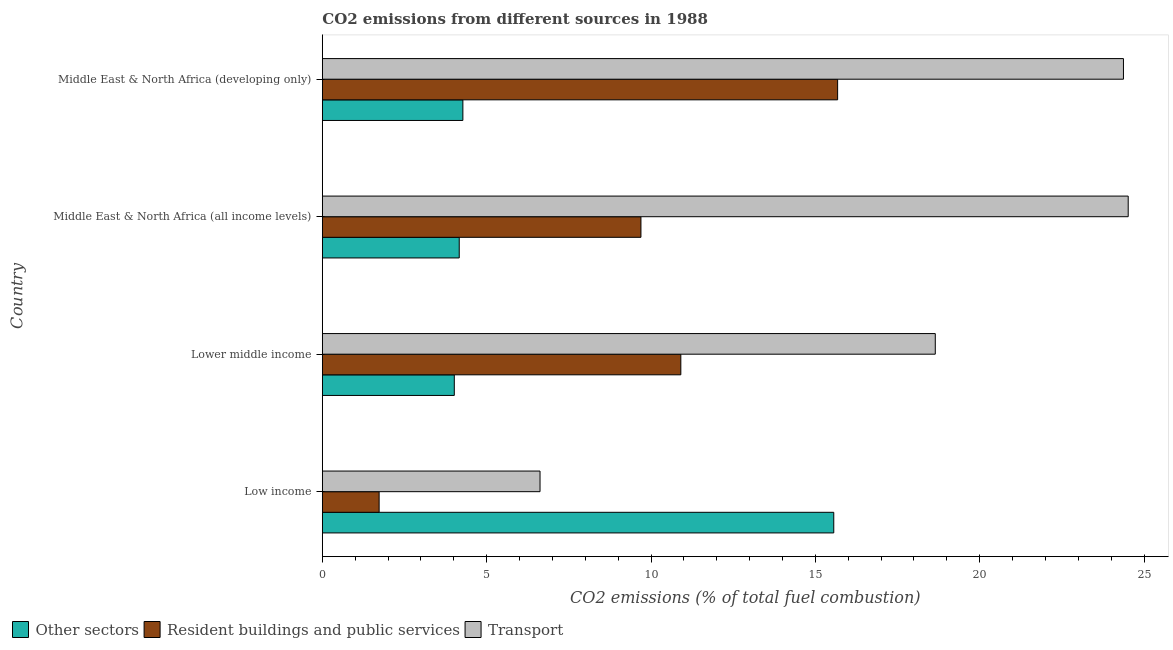How many different coloured bars are there?
Your answer should be very brief. 3. Are the number of bars per tick equal to the number of legend labels?
Your answer should be compact. Yes. Are the number of bars on each tick of the Y-axis equal?
Give a very brief answer. Yes. How many bars are there on the 3rd tick from the top?
Your answer should be compact. 3. What is the label of the 1st group of bars from the top?
Your response must be concise. Middle East & North Africa (developing only). What is the percentage of co2 emissions from other sectors in Lower middle income?
Offer a terse response. 4.02. Across all countries, what is the maximum percentage of co2 emissions from other sectors?
Offer a very short reply. 15.56. Across all countries, what is the minimum percentage of co2 emissions from resident buildings and public services?
Keep it short and to the point. 1.73. In which country was the percentage of co2 emissions from other sectors maximum?
Make the answer very short. Low income. What is the total percentage of co2 emissions from other sectors in the graph?
Provide a short and direct response. 28.02. What is the difference between the percentage of co2 emissions from transport in Lower middle income and that in Middle East & North Africa (developing only)?
Make the answer very short. -5.72. What is the difference between the percentage of co2 emissions from transport in Middle East & North Africa (all income levels) and the percentage of co2 emissions from resident buildings and public services in Middle East & North Africa (developing only)?
Your answer should be compact. 8.84. What is the average percentage of co2 emissions from other sectors per country?
Offer a terse response. 7. What is the difference between the percentage of co2 emissions from transport and percentage of co2 emissions from resident buildings and public services in Middle East & North Africa (all income levels)?
Your answer should be compact. 14.82. What is the ratio of the percentage of co2 emissions from resident buildings and public services in Low income to that in Lower middle income?
Keep it short and to the point. 0.16. What is the difference between the highest and the second highest percentage of co2 emissions from resident buildings and public services?
Your answer should be compact. 4.77. What is the difference between the highest and the lowest percentage of co2 emissions from transport?
Your response must be concise. 17.89. What does the 1st bar from the top in Lower middle income represents?
Offer a very short reply. Transport. What does the 1st bar from the bottom in Low income represents?
Provide a succinct answer. Other sectors. Is it the case that in every country, the sum of the percentage of co2 emissions from other sectors and percentage of co2 emissions from resident buildings and public services is greater than the percentage of co2 emissions from transport?
Offer a very short reply. No. Are all the bars in the graph horizontal?
Provide a succinct answer. Yes. What is the difference between two consecutive major ticks on the X-axis?
Keep it short and to the point. 5. Are the values on the major ticks of X-axis written in scientific E-notation?
Your response must be concise. No. Does the graph contain any zero values?
Offer a very short reply. No. Does the graph contain grids?
Provide a succinct answer. No. Where does the legend appear in the graph?
Your response must be concise. Bottom left. How many legend labels are there?
Provide a short and direct response. 3. How are the legend labels stacked?
Make the answer very short. Horizontal. What is the title of the graph?
Keep it short and to the point. CO2 emissions from different sources in 1988. What is the label or title of the X-axis?
Offer a very short reply. CO2 emissions (% of total fuel combustion). What is the label or title of the Y-axis?
Offer a terse response. Country. What is the CO2 emissions (% of total fuel combustion) in Other sectors in Low income?
Your answer should be compact. 15.56. What is the CO2 emissions (% of total fuel combustion) in Resident buildings and public services in Low income?
Give a very brief answer. 1.73. What is the CO2 emissions (% of total fuel combustion) in Transport in Low income?
Ensure brevity in your answer.  6.62. What is the CO2 emissions (% of total fuel combustion) in Other sectors in Lower middle income?
Provide a succinct answer. 4.02. What is the CO2 emissions (% of total fuel combustion) in Resident buildings and public services in Lower middle income?
Provide a short and direct response. 10.91. What is the CO2 emissions (% of total fuel combustion) of Transport in Lower middle income?
Your answer should be compact. 18.65. What is the CO2 emissions (% of total fuel combustion) of Other sectors in Middle East & North Africa (all income levels)?
Offer a terse response. 4.17. What is the CO2 emissions (% of total fuel combustion) of Resident buildings and public services in Middle East & North Africa (all income levels)?
Ensure brevity in your answer.  9.69. What is the CO2 emissions (% of total fuel combustion) in Transport in Middle East & North Africa (all income levels)?
Offer a terse response. 24.52. What is the CO2 emissions (% of total fuel combustion) of Other sectors in Middle East & North Africa (developing only)?
Keep it short and to the point. 4.28. What is the CO2 emissions (% of total fuel combustion) of Resident buildings and public services in Middle East & North Africa (developing only)?
Offer a very short reply. 15.68. What is the CO2 emissions (% of total fuel combustion) of Transport in Middle East & North Africa (developing only)?
Offer a terse response. 24.37. Across all countries, what is the maximum CO2 emissions (% of total fuel combustion) of Other sectors?
Ensure brevity in your answer.  15.56. Across all countries, what is the maximum CO2 emissions (% of total fuel combustion) of Resident buildings and public services?
Provide a short and direct response. 15.68. Across all countries, what is the maximum CO2 emissions (% of total fuel combustion) in Transport?
Ensure brevity in your answer.  24.52. Across all countries, what is the minimum CO2 emissions (% of total fuel combustion) in Other sectors?
Make the answer very short. 4.02. Across all countries, what is the minimum CO2 emissions (% of total fuel combustion) in Resident buildings and public services?
Provide a succinct answer. 1.73. Across all countries, what is the minimum CO2 emissions (% of total fuel combustion) of Transport?
Keep it short and to the point. 6.62. What is the total CO2 emissions (% of total fuel combustion) of Other sectors in the graph?
Offer a terse response. 28.02. What is the total CO2 emissions (% of total fuel combustion) in Resident buildings and public services in the graph?
Provide a succinct answer. 38. What is the total CO2 emissions (% of total fuel combustion) in Transport in the graph?
Your answer should be compact. 74.16. What is the difference between the CO2 emissions (% of total fuel combustion) of Other sectors in Low income and that in Lower middle income?
Offer a very short reply. 11.54. What is the difference between the CO2 emissions (% of total fuel combustion) of Resident buildings and public services in Low income and that in Lower middle income?
Ensure brevity in your answer.  -9.18. What is the difference between the CO2 emissions (% of total fuel combustion) of Transport in Low income and that in Lower middle income?
Offer a very short reply. -12.02. What is the difference between the CO2 emissions (% of total fuel combustion) in Other sectors in Low income and that in Middle East & North Africa (all income levels)?
Make the answer very short. 11.39. What is the difference between the CO2 emissions (% of total fuel combustion) in Resident buildings and public services in Low income and that in Middle East & North Africa (all income levels)?
Give a very brief answer. -7.96. What is the difference between the CO2 emissions (% of total fuel combustion) of Transport in Low income and that in Middle East & North Africa (all income levels)?
Keep it short and to the point. -17.89. What is the difference between the CO2 emissions (% of total fuel combustion) of Other sectors in Low income and that in Middle East & North Africa (developing only)?
Offer a terse response. 11.28. What is the difference between the CO2 emissions (% of total fuel combustion) in Resident buildings and public services in Low income and that in Middle East & North Africa (developing only)?
Your response must be concise. -13.95. What is the difference between the CO2 emissions (% of total fuel combustion) in Transport in Low income and that in Middle East & North Africa (developing only)?
Offer a terse response. -17.75. What is the difference between the CO2 emissions (% of total fuel combustion) of Resident buildings and public services in Lower middle income and that in Middle East & North Africa (all income levels)?
Provide a succinct answer. 1.21. What is the difference between the CO2 emissions (% of total fuel combustion) in Transport in Lower middle income and that in Middle East & North Africa (all income levels)?
Offer a very short reply. -5.87. What is the difference between the CO2 emissions (% of total fuel combustion) of Other sectors in Lower middle income and that in Middle East & North Africa (developing only)?
Your answer should be compact. -0.26. What is the difference between the CO2 emissions (% of total fuel combustion) of Resident buildings and public services in Lower middle income and that in Middle East & North Africa (developing only)?
Ensure brevity in your answer.  -4.77. What is the difference between the CO2 emissions (% of total fuel combustion) in Transport in Lower middle income and that in Middle East & North Africa (developing only)?
Make the answer very short. -5.72. What is the difference between the CO2 emissions (% of total fuel combustion) of Other sectors in Middle East & North Africa (all income levels) and that in Middle East & North Africa (developing only)?
Your answer should be compact. -0.11. What is the difference between the CO2 emissions (% of total fuel combustion) of Resident buildings and public services in Middle East & North Africa (all income levels) and that in Middle East & North Africa (developing only)?
Make the answer very short. -5.98. What is the difference between the CO2 emissions (% of total fuel combustion) of Transport in Middle East & North Africa (all income levels) and that in Middle East & North Africa (developing only)?
Keep it short and to the point. 0.14. What is the difference between the CO2 emissions (% of total fuel combustion) in Other sectors in Low income and the CO2 emissions (% of total fuel combustion) in Resident buildings and public services in Lower middle income?
Give a very brief answer. 4.65. What is the difference between the CO2 emissions (% of total fuel combustion) of Other sectors in Low income and the CO2 emissions (% of total fuel combustion) of Transport in Lower middle income?
Make the answer very short. -3.09. What is the difference between the CO2 emissions (% of total fuel combustion) of Resident buildings and public services in Low income and the CO2 emissions (% of total fuel combustion) of Transport in Lower middle income?
Offer a very short reply. -16.92. What is the difference between the CO2 emissions (% of total fuel combustion) in Other sectors in Low income and the CO2 emissions (% of total fuel combustion) in Resident buildings and public services in Middle East & North Africa (all income levels)?
Offer a terse response. 5.87. What is the difference between the CO2 emissions (% of total fuel combustion) in Other sectors in Low income and the CO2 emissions (% of total fuel combustion) in Transport in Middle East & North Africa (all income levels)?
Your answer should be compact. -8.96. What is the difference between the CO2 emissions (% of total fuel combustion) of Resident buildings and public services in Low income and the CO2 emissions (% of total fuel combustion) of Transport in Middle East & North Africa (all income levels)?
Ensure brevity in your answer.  -22.79. What is the difference between the CO2 emissions (% of total fuel combustion) of Other sectors in Low income and the CO2 emissions (% of total fuel combustion) of Resident buildings and public services in Middle East & North Africa (developing only)?
Provide a short and direct response. -0.12. What is the difference between the CO2 emissions (% of total fuel combustion) in Other sectors in Low income and the CO2 emissions (% of total fuel combustion) in Transport in Middle East & North Africa (developing only)?
Make the answer very short. -8.81. What is the difference between the CO2 emissions (% of total fuel combustion) of Resident buildings and public services in Low income and the CO2 emissions (% of total fuel combustion) of Transport in Middle East & North Africa (developing only)?
Make the answer very short. -22.64. What is the difference between the CO2 emissions (% of total fuel combustion) of Other sectors in Lower middle income and the CO2 emissions (% of total fuel combustion) of Resident buildings and public services in Middle East & North Africa (all income levels)?
Ensure brevity in your answer.  -5.68. What is the difference between the CO2 emissions (% of total fuel combustion) in Other sectors in Lower middle income and the CO2 emissions (% of total fuel combustion) in Transport in Middle East & North Africa (all income levels)?
Your answer should be very brief. -20.5. What is the difference between the CO2 emissions (% of total fuel combustion) of Resident buildings and public services in Lower middle income and the CO2 emissions (% of total fuel combustion) of Transport in Middle East & North Africa (all income levels)?
Provide a short and direct response. -13.61. What is the difference between the CO2 emissions (% of total fuel combustion) of Other sectors in Lower middle income and the CO2 emissions (% of total fuel combustion) of Resident buildings and public services in Middle East & North Africa (developing only)?
Your answer should be compact. -11.66. What is the difference between the CO2 emissions (% of total fuel combustion) of Other sectors in Lower middle income and the CO2 emissions (% of total fuel combustion) of Transport in Middle East & North Africa (developing only)?
Provide a short and direct response. -20.36. What is the difference between the CO2 emissions (% of total fuel combustion) in Resident buildings and public services in Lower middle income and the CO2 emissions (% of total fuel combustion) in Transport in Middle East & North Africa (developing only)?
Keep it short and to the point. -13.47. What is the difference between the CO2 emissions (% of total fuel combustion) in Other sectors in Middle East & North Africa (all income levels) and the CO2 emissions (% of total fuel combustion) in Resident buildings and public services in Middle East & North Africa (developing only)?
Provide a short and direct response. -11.51. What is the difference between the CO2 emissions (% of total fuel combustion) in Other sectors in Middle East & North Africa (all income levels) and the CO2 emissions (% of total fuel combustion) in Transport in Middle East & North Africa (developing only)?
Ensure brevity in your answer.  -20.21. What is the difference between the CO2 emissions (% of total fuel combustion) of Resident buildings and public services in Middle East & North Africa (all income levels) and the CO2 emissions (% of total fuel combustion) of Transport in Middle East & North Africa (developing only)?
Provide a short and direct response. -14.68. What is the average CO2 emissions (% of total fuel combustion) of Other sectors per country?
Provide a succinct answer. 7. What is the average CO2 emissions (% of total fuel combustion) in Resident buildings and public services per country?
Your answer should be compact. 9.5. What is the average CO2 emissions (% of total fuel combustion) of Transport per country?
Your answer should be compact. 18.54. What is the difference between the CO2 emissions (% of total fuel combustion) in Other sectors and CO2 emissions (% of total fuel combustion) in Resident buildings and public services in Low income?
Provide a short and direct response. 13.83. What is the difference between the CO2 emissions (% of total fuel combustion) of Other sectors and CO2 emissions (% of total fuel combustion) of Transport in Low income?
Give a very brief answer. 8.94. What is the difference between the CO2 emissions (% of total fuel combustion) in Resident buildings and public services and CO2 emissions (% of total fuel combustion) in Transport in Low income?
Keep it short and to the point. -4.89. What is the difference between the CO2 emissions (% of total fuel combustion) in Other sectors and CO2 emissions (% of total fuel combustion) in Resident buildings and public services in Lower middle income?
Make the answer very short. -6.89. What is the difference between the CO2 emissions (% of total fuel combustion) of Other sectors and CO2 emissions (% of total fuel combustion) of Transport in Lower middle income?
Ensure brevity in your answer.  -14.63. What is the difference between the CO2 emissions (% of total fuel combustion) of Resident buildings and public services and CO2 emissions (% of total fuel combustion) of Transport in Lower middle income?
Your answer should be very brief. -7.74. What is the difference between the CO2 emissions (% of total fuel combustion) in Other sectors and CO2 emissions (% of total fuel combustion) in Resident buildings and public services in Middle East & North Africa (all income levels)?
Offer a terse response. -5.53. What is the difference between the CO2 emissions (% of total fuel combustion) of Other sectors and CO2 emissions (% of total fuel combustion) of Transport in Middle East & North Africa (all income levels)?
Keep it short and to the point. -20.35. What is the difference between the CO2 emissions (% of total fuel combustion) in Resident buildings and public services and CO2 emissions (% of total fuel combustion) in Transport in Middle East & North Africa (all income levels)?
Keep it short and to the point. -14.82. What is the difference between the CO2 emissions (% of total fuel combustion) of Other sectors and CO2 emissions (% of total fuel combustion) of Resident buildings and public services in Middle East & North Africa (developing only)?
Make the answer very short. -11.4. What is the difference between the CO2 emissions (% of total fuel combustion) in Other sectors and CO2 emissions (% of total fuel combustion) in Transport in Middle East & North Africa (developing only)?
Provide a short and direct response. -20.1. What is the difference between the CO2 emissions (% of total fuel combustion) of Resident buildings and public services and CO2 emissions (% of total fuel combustion) of Transport in Middle East & North Africa (developing only)?
Offer a very short reply. -8.7. What is the ratio of the CO2 emissions (% of total fuel combustion) in Other sectors in Low income to that in Lower middle income?
Give a very brief answer. 3.88. What is the ratio of the CO2 emissions (% of total fuel combustion) in Resident buildings and public services in Low income to that in Lower middle income?
Provide a short and direct response. 0.16. What is the ratio of the CO2 emissions (% of total fuel combustion) in Transport in Low income to that in Lower middle income?
Keep it short and to the point. 0.36. What is the ratio of the CO2 emissions (% of total fuel combustion) in Other sectors in Low income to that in Middle East & North Africa (all income levels)?
Your answer should be very brief. 3.74. What is the ratio of the CO2 emissions (% of total fuel combustion) of Resident buildings and public services in Low income to that in Middle East & North Africa (all income levels)?
Your answer should be compact. 0.18. What is the ratio of the CO2 emissions (% of total fuel combustion) in Transport in Low income to that in Middle East & North Africa (all income levels)?
Your response must be concise. 0.27. What is the ratio of the CO2 emissions (% of total fuel combustion) in Other sectors in Low income to that in Middle East & North Africa (developing only)?
Make the answer very short. 3.64. What is the ratio of the CO2 emissions (% of total fuel combustion) of Resident buildings and public services in Low income to that in Middle East & North Africa (developing only)?
Offer a terse response. 0.11. What is the ratio of the CO2 emissions (% of total fuel combustion) in Transport in Low income to that in Middle East & North Africa (developing only)?
Provide a short and direct response. 0.27. What is the ratio of the CO2 emissions (% of total fuel combustion) in Resident buildings and public services in Lower middle income to that in Middle East & North Africa (all income levels)?
Offer a very short reply. 1.13. What is the ratio of the CO2 emissions (% of total fuel combustion) in Transport in Lower middle income to that in Middle East & North Africa (all income levels)?
Your answer should be compact. 0.76. What is the ratio of the CO2 emissions (% of total fuel combustion) of Other sectors in Lower middle income to that in Middle East & North Africa (developing only)?
Give a very brief answer. 0.94. What is the ratio of the CO2 emissions (% of total fuel combustion) in Resident buildings and public services in Lower middle income to that in Middle East & North Africa (developing only)?
Ensure brevity in your answer.  0.7. What is the ratio of the CO2 emissions (% of total fuel combustion) in Transport in Lower middle income to that in Middle East & North Africa (developing only)?
Your answer should be very brief. 0.77. What is the ratio of the CO2 emissions (% of total fuel combustion) in Other sectors in Middle East & North Africa (all income levels) to that in Middle East & North Africa (developing only)?
Your response must be concise. 0.97. What is the ratio of the CO2 emissions (% of total fuel combustion) of Resident buildings and public services in Middle East & North Africa (all income levels) to that in Middle East & North Africa (developing only)?
Keep it short and to the point. 0.62. What is the ratio of the CO2 emissions (% of total fuel combustion) in Transport in Middle East & North Africa (all income levels) to that in Middle East & North Africa (developing only)?
Offer a very short reply. 1.01. What is the difference between the highest and the second highest CO2 emissions (% of total fuel combustion) of Other sectors?
Keep it short and to the point. 11.28. What is the difference between the highest and the second highest CO2 emissions (% of total fuel combustion) of Resident buildings and public services?
Offer a terse response. 4.77. What is the difference between the highest and the second highest CO2 emissions (% of total fuel combustion) in Transport?
Provide a short and direct response. 0.14. What is the difference between the highest and the lowest CO2 emissions (% of total fuel combustion) in Other sectors?
Ensure brevity in your answer.  11.54. What is the difference between the highest and the lowest CO2 emissions (% of total fuel combustion) in Resident buildings and public services?
Your answer should be very brief. 13.95. What is the difference between the highest and the lowest CO2 emissions (% of total fuel combustion) of Transport?
Give a very brief answer. 17.89. 